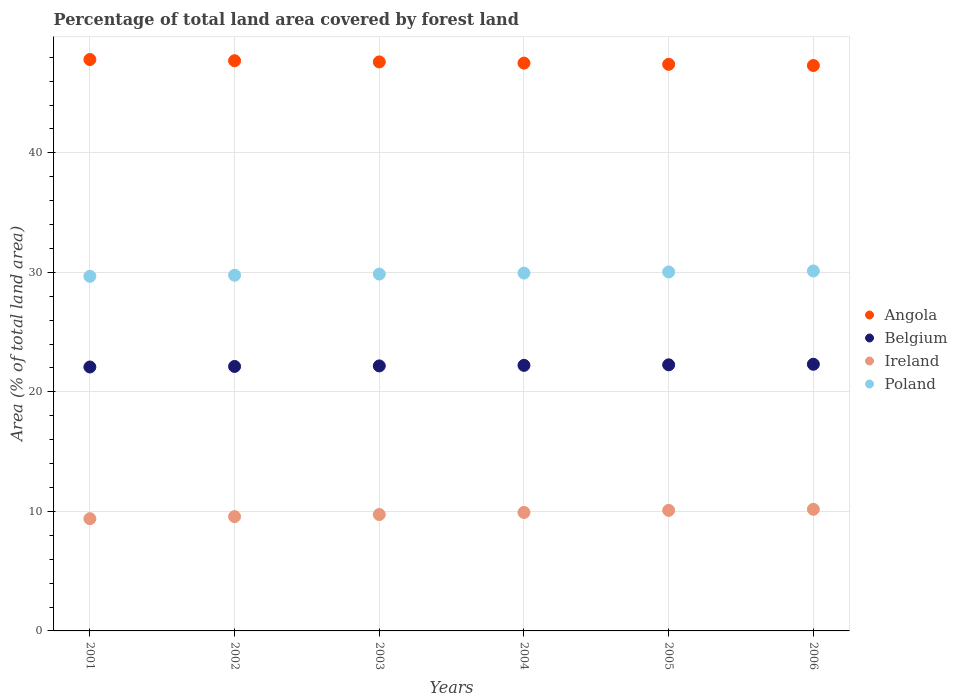How many different coloured dotlines are there?
Provide a succinct answer. 4. What is the percentage of forest land in Poland in 2005?
Make the answer very short. 30.03. Across all years, what is the maximum percentage of forest land in Ireland?
Make the answer very short. 10.18. Across all years, what is the minimum percentage of forest land in Angola?
Keep it short and to the point. 47.31. In which year was the percentage of forest land in Ireland minimum?
Provide a short and direct response. 2001. What is the total percentage of forest land in Belgium in the graph?
Your answer should be compact. 133.18. What is the difference between the percentage of forest land in Ireland in 2004 and that in 2006?
Your answer should be compact. -0.26. What is the difference between the percentage of forest land in Poland in 2003 and the percentage of forest land in Belgium in 2001?
Provide a short and direct response. 7.77. What is the average percentage of forest land in Ireland per year?
Your answer should be compact. 9.81. In the year 2006, what is the difference between the percentage of forest land in Belgium and percentage of forest land in Angola?
Provide a succinct answer. -25. What is the ratio of the percentage of forest land in Ireland in 2001 to that in 2006?
Give a very brief answer. 0.92. Is the percentage of forest land in Belgium in 2003 less than that in 2005?
Offer a very short reply. Yes. What is the difference between the highest and the second highest percentage of forest land in Angola?
Your answer should be very brief. 0.1. What is the difference between the highest and the lowest percentage of forest land in Belgium?
Offer a very short reply. 0.23. Does the percentage of forest land in Poland monotonically increase over the years?
Offer a terse response. Yes. How many dotlines are there?
Keep it short and to the point. 4. How many years are there in the graph?
Keep it short and to the point. 6. Are the values on the major ticks of Y-axis written in scientific E-notation?
Give a very brief answer. No. Does the graph contain any zero values?
Your answer should be compact. No. How many legend labels are there?
Ensure brevity in your answer.  4. What is the title of the graph?
Offer a very short reply. Percentage of total land area covered by forest land. What is the label or title of the X-axis?
Ensure brevity in your answer.  Years. What is the label or title of the Y-axis?
Keep it short and to the point. Area (% of total land area). What is the Area (% of total land area) in Angola in 2001?
Provide a succinct answer. 47.81. What is the Area (% of total land area) in Belgium in 2001?
Make the answer very short. 22.08. What is the Area (% of total land area) in Ireland in 2001?
Make the answer very short. 9.39. What is the Area (% of total land area) of Poland in 2001?
Ensure brevity in your answer.  29.67. What is the Area (% of total land area) in Angola in 2002?
Ensure brevity in your answer.  47.71. What is the Area (% of total land area) in Belgium in 2002?
Your answer should be compact. 22.13. What is the Area (% of total land area) in Ireland in 2002?
Give a very brief answer. 9.56. What is the Area (% of total land area) in Poland in 2002?
Make the answer very short. 29.76. What is the Area (% of total land area) in Angola in 2003?
Offer a very short reply. 47.61. What is the Area (% of total land area) in Belgium in 2003?
Give a very brief answer. 22.17. What is the Area (% of total land area) in Ireland in 2003?
Make the answer very short. 9.74. What is the Area (% of total land area) in Poland in 2003?
Your response must be concise. 29.86. What is the Area (% of total land area) of Angola in 2004?
Your answer should be compact. 47.51. What is the Area (% of total land area) of Belgium in 2004?
Your answer should be compact. 22.22. What is the Area (% of total land area) in Ireland in 2004?
Ensure brevity in your answer.  9.91. What is the Area (% of total land area) in Poland in 2004?
Ensure brevity in your answer.  29.94. What is the Area (% of total land area) in Angola in 2005?
Keep it short and to the point. 47.41. What is the Area (% of total land area) of Belgium in 2005?
Ensure brevity in your answer.  22.27. What is the Area (% of total land area) of Ireland in 2005?
Make the answer very short. 10.09. What is the Area (% of total land area) in Poland in 2005?
Give a very brief answer. 30.03. What is the Area (% of total land area) in Angola in 2006?
Offer a very short reply. 47.31. What is the Area (% of total land area) in Belgium in 2006?
Your answer should be very brief. 22.31. What is the Area (% of total land area) of Ireland in 2006?
Offer a terse response. 10.18. What is the Area (% of total land area) of Poland in 2006?
Keep it short and to the point. 30.12. Across all years, what is the maximum Area (% of total land area) of Angola?
Ensure brevity in your answer.  47.81. Across all years, what is the maximum Area (% of total land area) of Belgium?
Offer a terse response. 22.31. Across all years, what is the maximum Area (% of total land area) of Ireland?
Your response must be concise. 10.18. Across all years, what is the maximum Area (% of total land area) in Poland?
Your response must be concise. 30.12. Across all years, what is the minimum Area (% of total land area) of Angola?
Ensure brevity in your answer.  47.31. Across all years, what is the minimum Area (% of total land area) in Belgium?
Offer a terse response. 22.08. Across all years, what is the minimum Area (% of total land area) in Ireland?
Keep it short and to the point. 9.39. Across all years, what is the minimum Area (% of total land area) of Poland?
Ensure brevity in your answer.  29.67. What is the total Area (% of total land area) of Angola in the graph?
Offer a terse response. 285.35. What is the total Area (% of total land area) in Belgium in the graph?
Give a very brief answer. 133.18. What is the total Area (% of total land area) in Ireland in the graph?
Give a very brief answer. 58.87. What is the total Area (% of total land area) in Poland in the graph?
Offer a terse response. 179.38. What is the difference between the Area (% of total land area) in Angola in 2001 and that in 2002?
Offer a very short reply. 0.1. What is the difference between the Area (% of total land area) of Belgium in 2001 and that in 2002?
Your answer should be very brief. -0.05. What is the difference between the Area (% of total land area) in Ireland in 2001 and that in 2002?
Keep it short and to the point. -0.17. What is the difference between the Area (% of total land area) in Poland in 2001 and that in 2002?
Your answer should be very brief. -0.09. What is the difference between the Area (% of total land area) of Angola in 2001 and that in 2003?
Give a very brief answer. 0.2. What is the difference between the Area (% of total land area) of Belgium in 2001 and that in 2003?
Ensure brevity in your answer.  -0.09. What is the difference between the Area (% of total land area) of Ireland in 2001 and that in 2003?
Your answer should be very brief. -0.35. What is the difference between the Area (% of total land area) in Poland in 2001 and that in 2003?
Your response must be concise. -0.19. What is the difference between the Area (% of total land area) of Angola in 2001 and that in 2004?
Offer a very short reply. 0.3. What is the difference between the Area (% of total land area) in Belgium in 2001 and that in 2004?
Make the answer very short. -0.14. What is the difference between the Area (% of total land area) of Ireland in 2001 and that in 2004?
Ensure brevity in your answer.  -0.52. What is the difference between the Area (% of total land area) of Poland in 2001 and that in 2004?
Your answer should be very brief. -0.27. What is the difference between the Area (% of total land area) in Angola in 2001 and that in 2005?
Offer a very short reply. 0.4. What is the difference between the Area (% of total land area) of Belgium in 2001 and that in 2005?
Give a very brief answer. -0.18. What is the difference between the Area (% of total land area) in Ireland in 2001 and that in 2005?
Make the answer very short. -0.7. What is the difference between the Area (% of total land area) of Poland in 2001 and that in 2005?
Provide a succinct answer. -0.36. What is the difference between the Area (% of total land area) in Angola in 2001 and that in 2006?
Offer a very short reply. 0.5. What is the difference between the Area (% of total land area) of Belgium in 2001 and that in 2006?
Give a very brief answer. -0.23. What is the difference between the Area (% of total land area) in Ireland in 2001 and that in 2006?
Provide a succinct answer. -0.78. What is the difference between the Area (% of total land area) of Poland in 2001 and that in 2006?
Your answer should be compact. -0.45. What is the difference between the Area (% of total land area) of Angola in 2002 and that in 2003?
Ensure brevity in your answer.  0.1. What is the difference between the Area (% of total land area) of Belgium in 2002 and that in 2003?
Ensure brevity in your answer.  -0.05. What is the difference between the Area (% of total land area) in Ireland in 2002 and that in 2003?
Provide a short and direct response. -0.17. What is the difference between the Area (% of total land area) of Poland in 2002 and that in 2003?
Your answer should be compact. -0.1. What is the difference between the Area (% of total land area) in Angola in 2002 and that in 2004?
Offer a very short reply. 0.2. What is the difference between the Area (% of total land area) of Belgium in 2002 and that in 2004?
Offer a terse response. -0.09. What is the difference between the Area (% of total land area) of Ireland in 2002 and that in 2004?
Make the answer very short. -0.35. What is the difference between the Area (% of total land area) in Poland in 2002 and that in 2004?
Your answer should be very brief. -0.18. What is the difference between the Area (% of total land area) in Angola in 2002 and that in 2005?
Your answer should be compact. 0.3. What is the difference between the Area (% of total land area) in Belgium in 2002 and that in 2005?
Ensure brevity in your answer.  -0.14. What is the difference between the Area (% of total land area) of Ireland in 2002 and that in 2005?
Provide a succinct answer. -0.52. What is the difference between the Area (% of total land area) of Poland in 2002 and that in 2005?
Your response must be concise. -0.27. What is the difference between the Area (% of total land area) of Angola in 2002 and that in 2006?
Offer a very short reply. 0.4. What is the difference between the Area (% of total land area) in Belgium in 2002 and that in 2006?
Make the answer very short. -0.18. What is the difference between the Area (% of total land area) of Ireland in 2002 and that in 2006?
Provide a short and direct response. -0.61. What is the difference between the Area (% of total land area) in Poland in 2002 and that in 2006?
Your response must be concise. -0.36. What is the difference between the Area (% of total land area) of Angola in 2003 and that in 2004?
Make the answer very short. 0.1. What is the difference between the Area (% of total land area) of Belgium in 2003 and that in 2004?
Ensure brevity in your answer.  -0.05. What is the difference between the Area (% of total land area) in Ireland in 2003 and that in 2004?
Give a very brief answer. -0.17. What is the difference between the Area (% of total land area) of Poland in 2003 and that in 2004?
Keep it short and to the point. -0.08. What is the difference between the Area (% of total land area) in Angola in 2003 and that in 2005?
Make the answer very short. 0.2. What is the difference between the Area (% of total land area) in Belgium in 2003 and that in 2005?
Your answer should be compact. -0.09. What is the difference between the Area (% of total land area) of Ireland in 2003 and that in 2005?
Your response must be concise. -0.35. What is the difference between the Area (% of total land area) in Poland in 2003 and that in 2005?
Your response must be concise. -0.18. What is the difference between the Area (% of total land area) of Angola in 2003 and that in 2006?
Ensure brevity in your answer.  0.3. What is the difference between the Area (% of total land area) in Belgium in 2003 and that in 2006?
Your answer should be very brief. -0.14. What is the difference between the Area (% of total land area) in Ireland in 2003 and that in 2006?
Provide a succinct answer. -0.44. What is the difference between the Area (% of total land area) of Poland in 2003 and that in 2006?
Your answer should be very brief. -0.26. What is the difference between the Area (% of total land area) in Angola in 2004 and that in 2005?
Keep it short and to the point. 0.1. What is the difference between the Area (% of total land area) of Belgium in 2004 and that in 2005?
Provide a succinct answer. -0.05. What is the difference between the Area (% of total land area) in Ireland in 2004 and that in 2005?
Provide a short and direct response. -0.17. What is the difference between the Area (% of total land area) of Poland in 2004 and that in 2005?
Keep it short and to the point. -0.09. What is the difference between the Area (% of total land area) in Angola in 2004 and that in 2006?
Keep it short and to the point. 0.2. What is the difference between the Area (% of total land area) in Belgium in 2004 and that in 2006?
Give a very brief answer. -0.09. What is the difference between the Area (% of total land area) in Ireland in 2004 and that in 2006?
Make the answer very short. -0.26. What is the difference between the Area (% of total land area) in Poland in 2004 and that in 2006?
Provide a succinct answer. -0.18. What is the difference between the Area (% of total land area) of Angola in 2005 and that in 2006?
Offer a very short reply. 0.1. What is the difference between the Area (% of total land area) in Belgium in 2005 and that in 2006?
Your response must be concise. -0.05. What is the difference between the Area (% of total land area) in Ireland in 2005 and that in 2006?
Your response must be concise. -0.09. What is the difference between the Area (% of total land area) in Poland in 2005 and that in 2006?
Give a very brief answer. -0.09. What is the difference between the Area (% of total land area) in Angola in 2001 and the Area (% of total land area) in Belgium in 2002?
Provide a short and direct response. 25.68. What is the difference between the Area (% of total land area) of Angola in 2001 and the Area (% of total land area) of Ireland in 2002?
Provide a short and direct response. 38.24. What is the difference between the Area (% of total land area) of Angola in 2001 and the Area (% of total land area) of Poland in 2002?
Your answer should be compact. 18.05. What is the difference between the Area (% of total land area) in Belgium in 2001 and the Area (% of total land area) in Ireland in 2002?
Offer a terse response. 12.52. What is the difference between the Area (% of total land area) in Belgium in 2001 and the Area (% of total land area) in Poland in 2002?
Your response must be concise. -7.68. What is the difference between the Area (% of total land area) of Ireland in 2001 and the Area (% of total land area) of Poland in 2002?
Keep it short and to the point. -20.37. What is the difference between the Area (% of total land area) of Angola in 2001 and the Area (% of total land area) of Belgium in 2003?
Your answer should be very brief. 25.63. What is the difference between the Area (% of total land area) in Angola in 2001 and the Area (% of total land area) in Ireland in 2003?
Your answer should be very brief. 38.07. What is the difference between the Area (% of total land area) in Angola in 2001 and the Area (% of total land area) in Poland in 2003?
Provide a succinct answer. 17.95. What is the difference between the Area (% of total land area) in Belgium in 2001 and the Area (% of total land area) in Ireland in 2003?
Offer a very short reply. 12.34. What is the difference between the Area (% of total land area) in Belgium in 2001 and the Area (% of total land area) in Poland in 2003?
Give a very brief answer. -7.77. What is the difference between the Area (% of total land area) in Ireland in 2001 and the Area (% of total land area) in Poland in 2003?
Offer a very short reply. -20.47. What is the difference between the Area (% of total land area) of Angola in 2001 and the Area (% of total land area) of Belgium in 2004?
Your answer should be very brief. 25.59. What is the difference between the Area (% of total land area) in Angola in 2001 and the Area (% of total land area) in Ireland in 2004?
Give a very brief answer. 37.9. What is the difference between the Area (% of total land area) in Angola in 2001 and the Area (% of total land area) in Poland in 2004?
Give a very brief answer. 17.87. What is the difference between the Area (% of total land area) of Belgium in 2001 and the Area (% of total land area) of Ireland in 2004?
Your answer should be very brief. 12.17. What is the difference between the Area (% of total land area) of Belgium in 2001 and the Area (% of total land area) of Poland in 2004?
Keep it short and to the point. -7.86. What is the difference between the Area (% of total land area) in Ireland in 2001 and the Area (% of total land area) in Poland in 2004?
Make the answer very short. -20.55. What is the difference between the Area (% of total land area) of Angola in 2001 and the Area (% of total land area) of Belgium in 2005?
Keep it short and to the point. 25.54. What is the difference between the Area (% of total land area) of Angola in 2001 and the Area (% of total land area) of Ireland in 2005?
Ensure brevity in your answer.  37.72. What is the difference between the Area (% of total land area) of Angola in 2001 and the Area (% of total land area) of Poland in 2005?
Keep it short and to the point. 17.78. What is the difference between the Area (% of total land area) in Belgium in 2001 and the Area (% of total land area) in Ireland in 2005?
Offer a very short reply. 12. What is the difference between the Area (% of total land area) in Belgium in 2001 and the Area (% of total land area) in Poland in 2005?
Keep it short and to the point. -7.95. What is the difference between the Area (% of total land area) of Ireland in 2001 and the Area (% of total land area) of Poland in 2005?
Provide a short and direct response. -20.64. What is the difference between the Area (% of total land area) in Angola in 2001 and the Area (% of total land area) in Belgium in 2006?
Provide a succinct answer. 25.5. What is the difference between the Area (% of total land area) of Angola in 2001 and the Area (% of total land area) of Ireland in 2006?
Ensure brevity in your answer.  37.63. What is the difference between the Area (% of total land area) of Angola in 2001 and the Area (% of total land area) of Poland in 2006?
Offer a terse response. 17.69. What is the difference between the Area (% of total land area) in Belgium in 2001 and the Area (% of total land area) in Ireland in 2006?
Make the answer very short. 11.91. What is the difference between the Area (% of total land area) of Belgium in 2001 and the Area (% of total land area) of Poland in 2006?
Your response must be concise. -8.04. What is the difference between the Area (% of total land area) in Ireland in 2001 and the Area (% of total land area) in Poland in 2006?
Give a very brief answer. -20.73. What is the difference between the Area (% of total land area) in Angola in 2002 and the Area (% of total land area) in Belgium in 2003?
Provide a short and direct response. 25.53. What is the difference between the Area (% of total land area) in Angola in 2002 and the Area (% of total land area) in Ireland in 2003?
Provide a succinct answer. 37.97. What is the difference between the Area (% of total land area) of Angola in 2002 and the Area (% of total land area) of Poland in 2003?
Make the answer very short. 17.85. What is the difference between the Area (% of total land area) of Belgium in 2002 and the Area (% of total land area) of Ireland in 2003?
Make the answer very short. 12.39. What is the difference between the Area (% of total land area) in Belgium in 2002 and the Area (% of total land area) in Poland in 2003?
Your answer should be very brief. -7.73. What is the difference between the Area (% of total land area) of Ireland in 2002 and the Area (% of total land area) of Poland in 2003?
Provide a succinct answer. -20.29. What is the difference between the Area (% of total land area) in Angola in 2002 and the Area (% of total land area) in Belgium in 2004?
Keep it short and to the point. 25.49. What is the difference between the Area (% of total land area) in Angola in 2002 and the Area (% of total land area) in Ireland in 2004?
Your answer should be very brief. 37.8. What is the difference between the Area (% of total land area) in Angola in 2002 and the Area (% of total land area) in Poland in 2004?
Ensure brevity in your answer.  17.77. What is the difference between the Area (% of total land area) in Belgium in 2002 and the Area (% of total land area) in Ireland in 2004?
Your answer should be compact. 12.22. What is the difference between the Area (% of total land area) in Belgium in 2002 and the Area (% of total land area) in Poland in 2004?
Your answer should be compact. -7.81. What is the difference between the Area (% of total land area) in Ireland in 2002 and the Area (% of total land area) in Poland in 2004?
Offer a very short reply. -20.38. What is the difference between the Area (% of total land area) in Angola in 2002 and the Area (% of total land area) in Belgium in 2005?
Make the answer very short. 25.44. What is the difference between the Area (% of total land area) of Angola in 2002 and the Area (% of total land area) of Ireland in 2005?
Give a very brief answer. 37.62. What is the difference between the Area (% of total land area) of Angola in 2002 and the Area (% of total land area) of Poland in 2005?
Your response must be concise. 17.68. What is the difference between the Area (% of total land area) in Belgium in 2002 and the Area (% of total land area) in Ireland in 2005?
Your answer should be compact. 12.04. What is the difference between the Area (% of total land area) in Belgium in 2002 and the Area (% of total land area) in Poland in 2005?
Your answer should be compact. -7.9. What is the difference between the Area (% of total land area) of Ireland in 2002 and the Area (% of total land area) of Poland in 2005?
Provide a short and direct response. -20.47. What is the difference between the Area (% of total land area) in Angola in 2002 and the Area (% of total land area) in Belgium in 2006?
Provide a succinct answer. 25.4. What is the difference between the Area (% of total land area) in Angola in 2002 and the Area (% of total land area) in Ireland in 2006?
Give a very brief answer. 37.53. What is the difference between the Area (% of total land area) of Angola in 2002 and the Area (% of total land area) of Poland in 2006?
Offer a very short reply. 17.59. What is the difference between the Area (% of total land area) in Belgium in 2002 and the Area (% of total land area) in Ireland in 2006?
Offer a very short reply. 11.95. What is the difference between the Area (% of total land area) of Belgium in 2002 and the Area (% of total land area) of Poland in 2006?
Ensure brevity in your answer.  -7.99. What is the difference between the Area (% of total land area) of Ireland in 2002 and the Area (% of total land area) of Poland in 2006?
Provide a succinct answer. -20.55. What is the difference between the Area (% of total land area) in Angola in 2003 and the Area (% of total land area) in Belgium in 2004?
Give a very brief answer. 25.39. What is the difference between the Area (% of total land area) in Angola in 2003 and the Area (% of total land area) in Ireland in 2004?
Your answer should be very brief. 37.7. What is the difference between the Area (% of total land area) of Angola in 2003 and the Area (% of total land area) of Poland in 2004?
Your answer should be very brief. 17.67. What is the difference between the Area (% of total land area) of Belgium in 2003 and the Area (% of total land area) of Ireland in 2004?
Give a very brief answer. 12.26. What is the difference between the Area (% of total land area) of Belgium in 2003 and the Area (% of total land area) of Poland in 2004?
Offer a very short reply. -7.77. What is the difference between the Area (% of total land area) of Ireland in 2003 and the Area (% of total land area) of Poland in 2004?
Your answer should be compact. -20.2. What is the difference between the Area (% of total land area) of Angola in 2003 and the Area (% of total land area) of Belgium in 2005?
Your response must be concise. 25.34. What is the difference between the Area (% of total land area) of Angola in 2003 and the Area (% of total land area) of Ireland in 2005?
Your response must be concise. 37.52. What is the difference between the Area (% of total land area) in Angola in 2003 and the Area (% of total land area) in Poland in 2005?
Your response must be concise. 17.58. What is the difference between the Area (% of total land area) in Belgium in 2003 and the Area (% of total land area) in Ireland in 2005?
Ensure brevity in your answer.  12.09. What is the difference between the Area (% of total land area) of Belgium in 2003 and the Area (% of total land area) of Poland in 2005?
Offer a very short reply. -7.86. What is the difference between the Area (% of total land area) in Ireland in 2003 and the Area (% of total land area) in Poland in 2005?
Provide a short and direct response. -20.29. What is the difference between the Area (% of total land area) in Angola in 2003 and the Area (% of total land area) in Belgium in 2006?
Make the answer very short. 25.3. What is the difference between the Area (% of total land area) of Angola in 2003 and the Area (% of total land area) of Ireland in 2006?
Your answer should be very brief. 37.43. What is the difference between the Area (% of total land area) of Angola in 2003 and the Area (% of total land area) of Poland in 2006?
Your answer should be very brief. 17.49. What is the difference between the Area (% of total land area) of Belgium in 2003 and the Area (% of total land area) of Ireland in 2006?
Give a very brief answer. 12. What is the difference between the Area (% of total land area) in Belgium in 2003 and the Area (% of total land area) in Poland in 2006?
Ensure brevity in your answer.  -7.94. What is the difference between the Area (% of total land area) in Ireland in 2003 and the Area (% of total land area) in Poland in 2006?
Offer a terse response. -20.38. What is the difference between the Area (% of total land area) in Angola in 2004 and the Area (% of total land area) in Belgium in 2005?
Your answer should be very brief. 25.24. What is the difference between the Area (% of total land area) in Angola in 2004 and the Area (% of total land area) in Ireland in 2005?
Make the answer very short. 37.42. What is the difference between the Area (% of total land area) in Angola in 2004 and the Area (% of total land area) in Poland in 2005?
Provide a short and direct response. 17.48. What is the difference between the Area (% of total land area) of Belgium in 2004 and the Area (% of total land area) of Ireland in 2005?
Offer a very short reply. 12.13. What is the difference between the Area (% of total land area) in Belgium in 2004 and the Area (% of total land area) in Poland in 2005?
Offer a terse response. -7.81. What is the difference between the Area (% of total land area) of Ireland in 2004 and the Area (% of total land area) of Poland in 2005?
Give a very brief answer. -20.12. What is the difference between the Area (% of total land area) in Angola in 2004 and the Area (% of total land area) in Belgium in 2006?
Your answer should be compact. 25.2. What is the difference between the Area (% of total land area) in Angola in 2004 and the Area (% of total land area) in Ireland in 2006?
Ensure brevity in your answer.  37.33. What is the difference between the Area (% of total land area) in Angola in 2004 and the Area (% of total land area) in Poland in 2006?
Your response must be concise. 17.39. What is the difference between the Area (% of total land area) of Belgium in 2004 and the Area (% of total land area) of Ireland in 2006?
Your response must be concise. 12.04. What is the difference between the Area (% of total land area) of Belgium in 2004 and the Area (% of total land area) of Poland in 2006?
Your response must be concise. -7.9. What is the difference between the Area (% of total land area) in Ireland in 2004 and the Area (% of total land area) in Poland in 2006?
Your answer should be compact. -20.21. What is the difference between the Area (% of total land area) in Angola in 2005 and the Area (% of total land area) in Belgium in 2006?
Your answer should be very brief. 25.1. What is the difference between the Area (% of total land area) in Angola in 2005 and the Area (% of total land area) in Ireland in 2006?
Provide a short and direct response. 37.23. What is the difference between the Area (% of total land area) in Angola in 2005 and the Area (% of total land area) in Poland in 2006?
Make the answer very short. 17.29. What is the difference between the Area (% of total land area) of Belgium in 2005 and the Area (% of total land area) of Ireland in 2006?
Offer a terse response. 12.09. What is the difference between the Area (% of total land area) of Belgium in 2005 and the Area (% of total land area) of Poland in 2006?
Offer a terse response. -7.85. What is the difference between the Area (% of total land area) of Ireland in 2005 and the Area (% of total land area) of Poland in 2006?
Offer a very short reply. -20.03. What is the average Area (% of total land area) of Angola per year?
Your answer should be compact. 47.56. What is the average Area (% of total land area) of Belgium per year?
Provide a short and direct response. 22.2. What is the average Area (% of total land area) in Ireland per year?
Provide a short and direct response. 9.81. What is the average Area (% of total land area) in Poland per year?
Keep it short and to the point. 29.9. In the year 2001, what is the difference between the Area (% of total land area) of Angola and Area (% of total land area) of Belgium?
Offer a very short reply. 25.73. In the year 2001, what is the difference between the Area (% of total land area) of Angola and Area (% of total land area) of Ireland?
Make the answer very short. 38.42. In the year 2001, what is the difference between the Area (% of total land area) of Angola and Area (% of total land area) of Poland?
Your answer should be very brief. 18.14. In the year 2001, what is the difference between the Area (% of total land area) in Belgium and Area (% of total land area) in Ireland?
Offer a very short reply. 12.69. In the year 2001, what is the difference between the Area (% of total land area) of Belgium and Area (% of total land area) of Poland?
Provide a short and direct response. -7.59. In the year 2001, what is the difference between the Area (% of total land area) of Ireland and Area (% of total land area) of Poland?
Ensure brevity in your answer.  -20.28. In the year 2002, what is the difference between the Area (% of total land area) in Angola and Area (% of total land area) in Belgium?
Provide a short and direct response. 25.58. In the year 2002, what is the difference between the Area (% of total land area) in Angola and Area (% of total land area) in Ireland?
Offer a very short reply. 38.14. In the year 2002, what is the difference between the Area (% of total land area) of Angola and Area (% of total land area) of Poland?
Make the answer very short. 17.95. In the year 2002, what is the difference between the Area (% of total land area) of Belgium and Area (% of total land area) of Ireland?
Offer a very short reply. 12.56. In the year 2002, what is the difference between the Area (% of total land area) in Belgium and Area (% of total land area) in Poland?
Ensure brevity in your answer.  -7.63. In the year 2002, what is the difference between the Area (% of total land area) of Ireland and Area (% of total land area) of Poland?
Your response must be concise. -20.2. In the year 2003, what is the difference between the Area (% of total land area) in Angola and Area (% of total land area) in Belgium?
Your response must be concise. 25.43. In the year 2003, what is the difference between the Area (% of total land area) in Angola and Area (% of total land area) in Ireland?
Ensure brevity in your answer.  37.87. In the year 2003, what is the difference between the Area (% of total land area) of Angola and Area (% of total land area) of Poland?
Provide a succinct answer. 17.75. In the year 2003, what is the difference between the Area (% of total land area) of Belgium and Area (% of total land area) of Ireland?
Provide a succinct answer. 12.44. In the year 2003, what is the difference between the Area (% of total land area) in Belgium and Area (% of total land area) in Poland?
Offer a very short reply. -7.68. In the year 2003, what is the difference between the Area (% of total land area) in Ireland and Area (% of total land area) in Poland?
Your answer should be very brief. -20.12. In the year 2004, what is the difference between the Area (% of total land area) of Angola and Area (% of total land area) of Belgium?
Give a very brief answer. 25.29. In the year 2004, what is the difference between the Area (% of total land area) in Angola and Area (% of total land area) in Ireland?
Make the answer very short. 37.6. In the year 2004, what is the difference between the Area (% of total land area) in Angola and Area (% of total land area) in Poland?
Your answer should be very brief. 17.57. In the year 2004, what is the difference between the Area (% of total land area) of Belgium and Area (% of total land area) of Ireland?
Give a very brief answer. 12.31. In the year 2004, what is the difference between the Area (% of total land area) in Belgium and Area (% of total land area) in Poland?
Your answer should be compact. -7.72. In the year 2004, what is the difference between the Area (% of total land area) in Ireland and Area (% of total land area) in Poland?
Provide a short and direct response. -20.03. In the year 2005, what is the difference between the Area (% of total land area) in Angola and Area (% of total land area) in Belgium?
Make the answer very short. 25.14. In the year 2005, what is the difference between the Area (% of total land area) in Angola and Area (% of total land area) in Ireland?
Ensure brevity in your answer.  37.32. In the year 2005, what is the difference between the Area (% of total land area) in Angola and Area (% of total land area) in Poland?
Your answer should be very brief. 17.38. In the year 2005, what is the difference between the Area (% of total land area) of Belgium and Area (% of total land area) of Ireland?
Provide a short and direct response. 12.18. In the year 2005, what is the difference between the Area (% of total land area) of Belgium and Area (% of total land area) of Poland?
Your answer should be very brief. -7.77. In the year 2005, what is the difference between the Area (% of total land area) of Ireland and Area (% of total land area) of Poland?
Your answer should be very brief. -19.95. In the year 2006, what is the difference between the Area (% of total land area) of Angola and Area (% of total land area) of Belgium?
Offer a terse response. 25. In the year 2006, what is the difference between the Area (% of total land area) of Angola and Area (% of total land area) of Ireland?
Your answer should be compact. 37.13. In the year 2006, what is the difference between the Area (% of total land area) of Angola and Area (% of total land area) of Poland?
Offer a terse response. 17.19. In the year 2006, what is the difference between the Area (% of total land area) in Belgium and Area (% of total land area) in Ireland?
Offer a very short reply. 12.14. In the year 2006, what is the difference between the Area (% of total land area) of Belgium and Area (% of total land area) of Poland?
Offer a very short reply. -7.81. In the year 2006, what is the difference between the Area (% of total land area) of Ireland and Area (% of total land area) of Poland?
Provide a short and direct response. -19.94. What is the ratio of the Area (% of total land area) of Belgium in 2001 to that in 2002?
Provide a short and direct response. 1. What is the ratio of the Area (% of total land area) of Ireland in 2001 to that in 2002?
Offer a very short reply. 0.98. What is the ratio of the Area (% of total land area) of Poland in 2001 to that in 2002?
Ensure brevity in your answer.  1. What is the ratio of the Area (% of total land area) in Poland in 2001 to that in 2003?
Offer a very short reply. 0.99. What is the ratio of the Area (% of total land area) of Angola in 2001 to that in 2004?
Give a very brief answer. 1.01. What is the ratio of the Area (% of total land area) in Belgium in 2001 to that in 2004?
Make the answer very short. 0.99. What is the ratio of the Area (% of total land area) in Poland in 2001 to that in 2004?
Keep it short and to the point. 0.99. What is the ratio of the Area (% of total land area) in Angola in 2001 to that in 2005?
Offer a very short reply. 1.01. What is the ratio of the Area (% of total land area) in Belgium in 2001 to that in 2005?
Make the answer very short. 0.99. What is the ratio of the Area (% of total land area) of Poland in 2001 to that in 2005?
Offer a very short reply. 0.99. What is the ratio of the Area (% of total land area) in Angola in 2001 to that in 2006?
Ensure brevity in your answer.  1.01. What is the ratio of the Area (% of total land area) of Ireland in 2001 to that in 2006?
Make the answer very short. 0.92. What is the ratio of the Area (% of total land area) in Poland in 2001 to that in 2006?
Provide a succinct answer. 0.99. What is the ratio of the Area (% of total land area) in Angola in 2002 to that in 2003?
Provide a succinct answer. 1. What is the ratio of the Area (% of total land area) in Ireland in 2002 to that in 2003?
Offer a terse response. 0.98. What is the ratio of the Area (% of total land area) in Angola in 2002 to that in 2004?
Your response must be concise. 1. What is the ratio of the Area (% of total land area) in Belgium in 2002 to that in 2004?
Make the answer very short. 1. What is the ratio of the Area (% of total land area) of Ireland in 2002 to that in 2004?
Ensure brevity in your answer.  0.96. What is the ratio of the Area (% of total land area) in Belgium in 2002 to that in 2005?
Ensure brevity in your answer.  0.99. What is the ratio of the Area (% of total land area) of Ireland in 2002 to that in 2005?
Your answer should be compact. 0.95. What is the ratio of the Area (% of total land area) in Poland in 2002 to that in 2005?
Offer a very short reply. 0.99. What is the ratio of the Area (% of total land area) of Angola in 2002 to that in 2006?
Offer a very short reply. 1.01. What is the ratio of the Area (% of total land area) in Ireland in 2002 to that in 2006?
Your answer should be very brief. 0.94. What is the ratio of the Area (% of total land area) of Ireland in 2003 to that in 2004?
Your answer should be compact. 0.98. What is the ratio of the Area (% of total land area) in Poland in 2003 to that in 2004?
Your answer should be compact. 1. What is the ratio of the Area (% of total land area) in Belgium in 2003 to that in 2005?
Make the answer very short. 1. What is the ratio of the Area (% of total land area) in Ireland in 2003 to that in 2005?
Offer a terse response. 0.97. What is the ratio of the Area (% of total land area) of Poland in 2003 to that in 2005?
Your answer should be compact. 0.99. What is the ratio of the Area (% of total land area) of Angola in 2004 to that in 2005?
Make the answer very short. 1. What is the ratio of the Area (% of total land area) of Belgium in 2004 to that in 2005?
Provide a short and direct response. 1. What is the ratio of the Area (% of total land area) in Ireland in 2004 to that in 2005?
Your answer should be compact. 0.98. What is the ratio of the Area (% of total land area) of Ireland in 2004 to that in 2006?
Your answer should be compact. 0.97. What is the ratio of the Area (% of total land area) of Poland in 2004 to that in 2006?
Keep it short and to the point. 0.99. What is the ratio of the Area (% of total land area) of Belgium in 2005 to that in 2006?
Your response must be concise. 1. What is the ratio of the Area (% of total land area) in Poland in 2005 to that in 2006?
Offer a very short reply. 1. What is the difference between the highest and the second highest Area (% of total land area) of Angola?
Offer a terse response. 0.1. What is the difference between the highest and the second highest Area (% of total land area) in Belgium?
Give a very brief answer. 0.05. What is the difference between the highest and the second highest Area (% of total land area) in Ireland?
Offer a very short reply. 0.09. What is the difference between the highest and the second highest Area (% of total land area) in Poland?
Ensure brevity in your answer.  0.09. What is the difference between the highest and the lowest Area (% of total land area) in Angola?
Your answer should be compact. 0.5. What is the difference between the highest and the lowest Area (% of total land area) in Belgium?
Keep it short and to the point. 0.23. What is the difference between the highest and the lowest Area (% of total land area) of Ireland?
Your answer should be very brief. 0.78. What is the difference between the highest and the lowest Area (% of total land area) in Poland?
Provide a succinct answer. 0.45. 